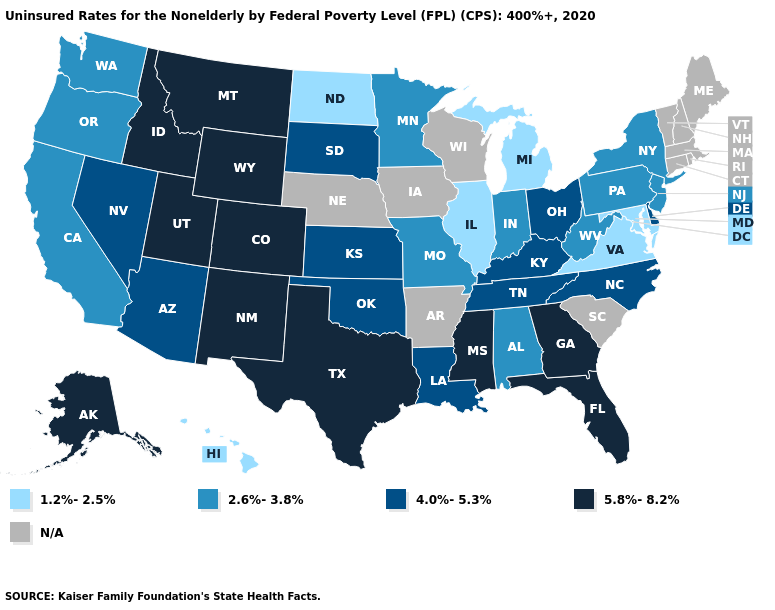Which states have the lowest value in the West?
Concise answer only. Hawaii. Name the states that have a value in the range 2.6%-3.8%?
Answer briefly. Alabama, California, Indiana, Minnesota, Missouri, New Jersey, New York, Oregon, Pennsylvania, Washington, West Virginia. Name the states that have a value in the range 4.0%-5.3%?
Quick response, please. Arizona, Delaware, Kansas, Kentucky, Louisiana, Nevada, North Carolina, Ohio, Oklahoma, South Dakota, Tennessee. Name the states that have a value in the range 1.2%-2.5%?
Give a very brief answer. Hawaii, Illinois, Maryland, Michigan, North Dakota, Virginia. Name the states that have a value in the range N/A?
Concise answer only. Arkansas, Connecticut, Iowa, Maine, Massachusetts, Nebraska, New Hampshire, Rhode Island, South Carolina, Vermont, Wisconsin. Name the states that have a value in the range N/A?
Give a very brief answer. Arkansas, Connecticut, Iowa, Maine, Massachusetts, Nebraska, New Hampshire, Rhode Island, South Carolina, Vermont, Wisconsin. Name the states that have a value in the range 5.8%-8.2%?
Answer briefly. Alaska, Colorado, Florida, Georgia, Idaho, Mississippi, Montana, New Mexico, Texas, Utah, Wyoming. Does the map have missing data?
Write a very short answer. Yes. How many symbols are there in the legend?
Keep it brief. 5. Name the states that have a value in the range 2.6%-3.8%?
Quick response, please. Alabama, California, Indiana, Minnesota, Missouri, New Jersey, New York, Oregon, Pennsylvania, Washington, West Virginia. What is the value of Delaware?
Write a very short answer. 4.0%-5.3%. Does Kansas have the highest value in the MidWest?
Keep it brief. Yes. How many symbols are there in the legend?
Quick response, please. 5. Name the states that have a value in the range 1.2%-2.5%?
Write a very short answer. Hawaii, Illinois, Maryland, Michigan, North Dakota, Virginia. 